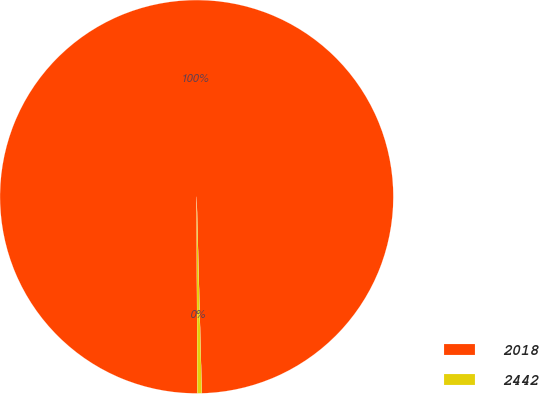Convert chart. <chart><loc_0><loc_0><loc_500><loc_500><pie_chart><fcel>2018<fcel>2442<nl><fcel>99.64%<fcel>0.36%<nl></chart> 